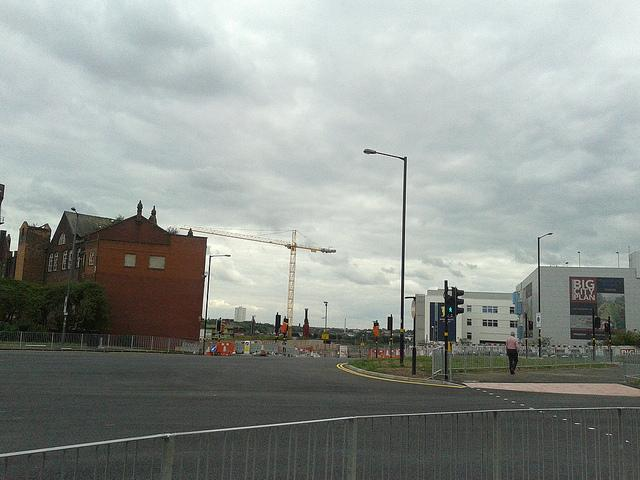What is the yellow structure in the background used for? lifting 